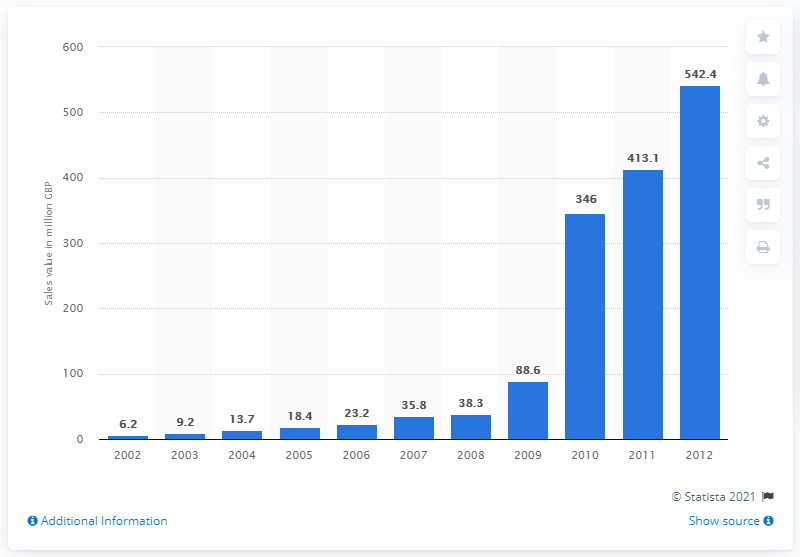Mention a couple of crucial points in this snapshot. The peak sales value of fairtrade chocolate between 2009 and 2012 was 542.4 million dollars. 